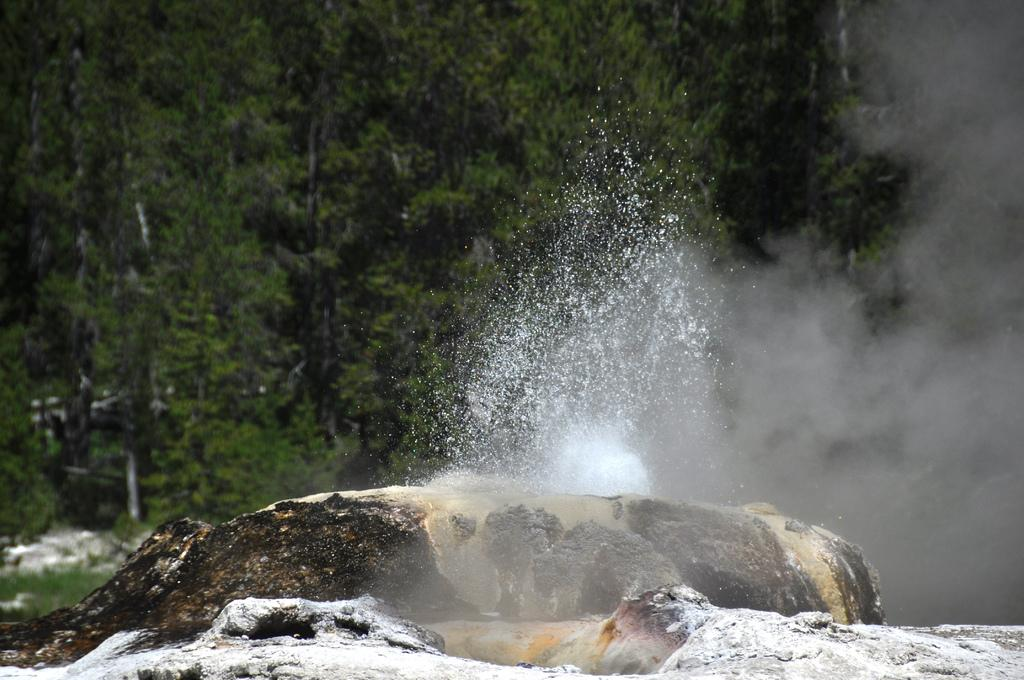What is the primary element visible in the image? There is water in the image. What other object can be seen in the image? There is a rock in the image. What else is present in the image besides water and the rock? There is smoke in the image. What can be seen in the background of the image? There are trees in the background of the image. How does the doll contribute to the harmony in the image? There is no doll present in the image, so it cannot contribute to the harmony. 